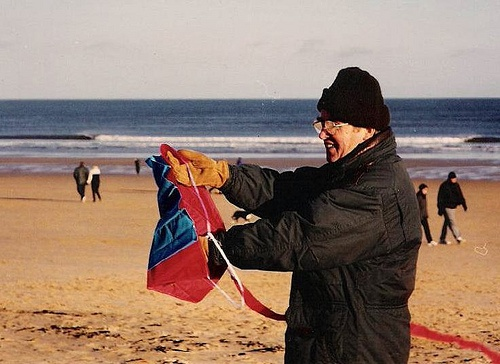Describe the objects in this image and their specific colors. I can see people in lightgray, black, maroon, tan, and gray tones, kite in lightgray, brown, black, tan, and navy tones, people in lightgray, black, tan, gray, and maroon tones, people in lightgray, black, maroon, gray, and tan tones, and people in lightgray, black, gray, and tan tones in this image. 